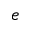Convert formula to latex. <formula><loc_0><loc_0><loc_500><loc_500>e</formula> 